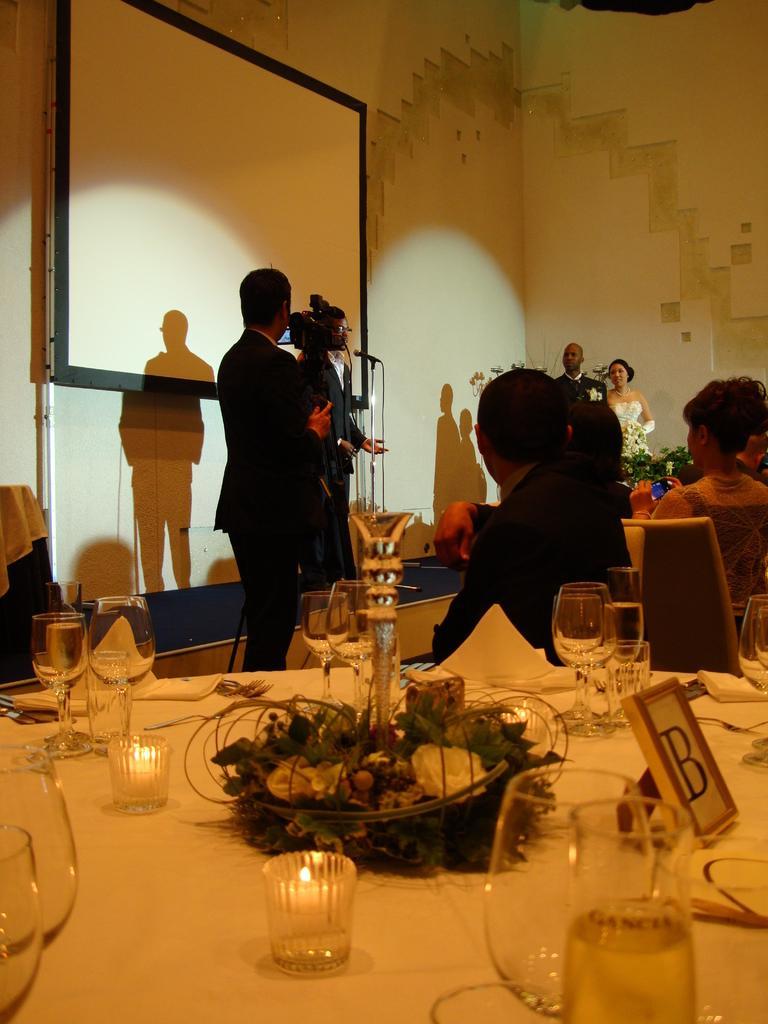Describe this image in one or two sentences. In the foreground there is a table, on the table there are glasses, candles, flower vase, tissues, name plate and other objects. In the middle of the picture there are people, camera, mic, stand, chairs and other objects. On the left there is a board. In the background it is well. 